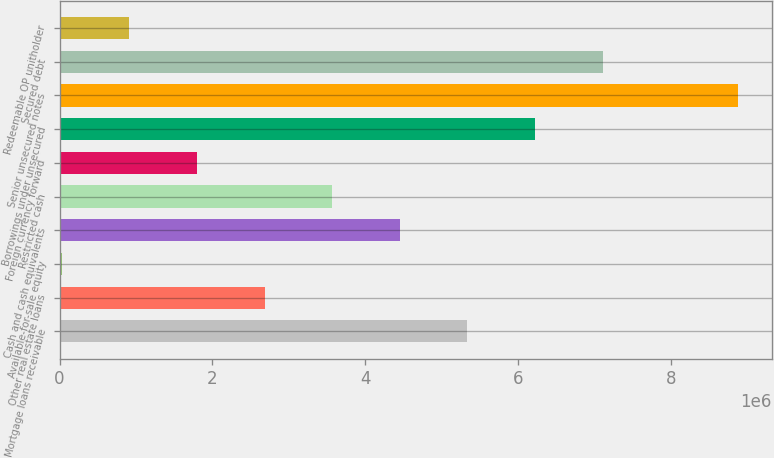Convert chart. <chart><loc_0><loc_0><loc_500><loc_500><bar_chart><fcel>Mortgage loans receivable<fcel>Other real estate loans<fcel>Available-for-sale equity<fcel>Cash and cash equivalents<fcel>Restricted cash<fcel>Foreign currency forward<fcel>Borrowings under unsecured<fcel>Senior unsecured notes<fcel>Secured debt<fcel>Redeemable OP unitholder<nl><fcel>5.33867e+06<fcel>2.68328e+06<fcel>27899<fcel>4.45354e+06<fcel>3.56841e+06<fcel>1.79815e+06<fcel>6.22379e+06<fcel>8.87918e+06<fcel>7.10892e+06<fcel>913027<nl></chart> 